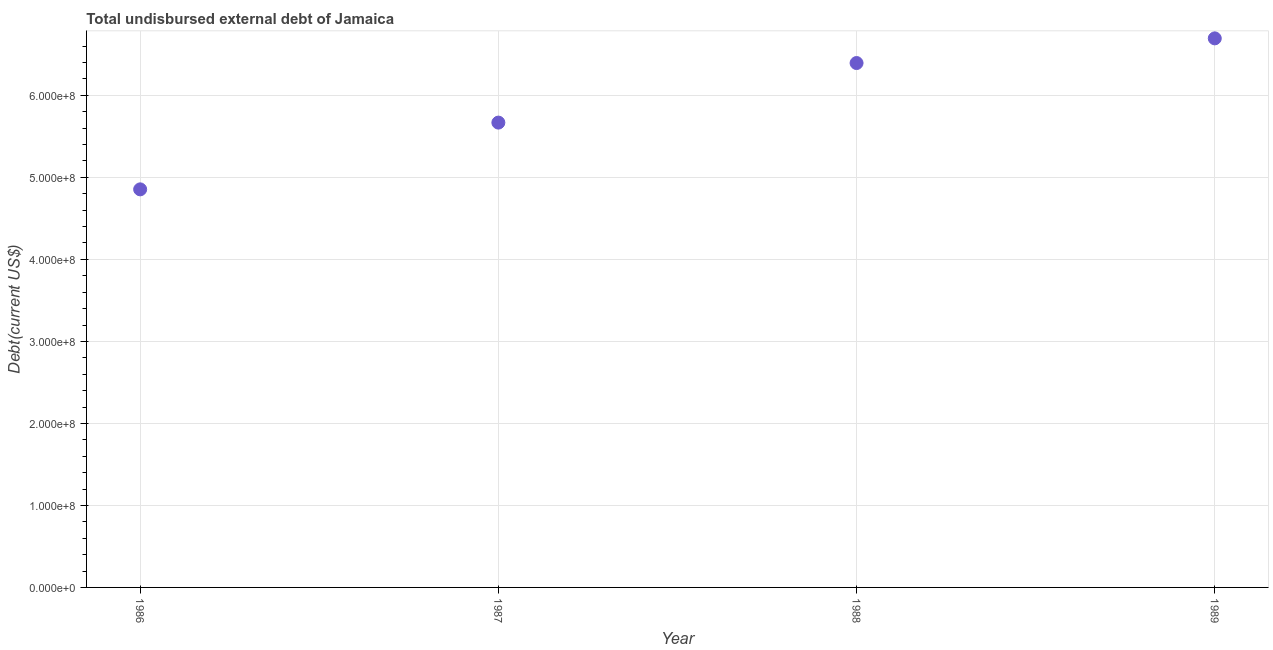What is the total debt in 1989?
Your answer should be very brief. 6.70e+08. Across all years, what is the maximum total debt?
Your answer should be very brief. 6.70e+08. Across all years, what is the minimum total debt?
Ensure brevity in your answer.  4.85e+08. In which year was the total debt maximum?
Provide a succinct answer. 1989. In which year was the total debt minimum?
Your answer should be compact. 1986. What is the sum of the total debt?
Your answer should be very brief. 2.36e+09. What is the difference between the total debt in 1987 and 1989?
Your answer should be very brief. -1.03e+08. What is the average total debt per year?
Offer a very short reply. 5.90e+08. What is the median total debt?
Ensure brevity in your answer.  6.03e+08. In how many years, is the total debt greater than 100000000 US$?
Offer a very short reply. 4. Do a majority of the years between 1986 and 1988 (inclusive) have total debt greater than 100000000 US$?
Provide a succinct answer. Yes. What is the ratio of the total debt in 1986 to that in 1987?
Give a very brief answer. 0.86. Is the difference between the total debt in 1987 and 1988 greater than the difference between any two years?
Your response must be concise. No. What is the difference between the highest and the second highest total debt?
Make the answer very short. 3.01e+07. Is the sum of the total debt in 1987 and 1988 greater than the maximum total debt across all years?
Provide a succinct answer. Yes. What is the difference between the highest and the lowest total debt?
Your answer should be very brief. 1.84e+08. In how many years, is the total debt greater than the average total debt taken over all years?
Offer a terse response. 2. Does the total debt monotonically increase over the years?
Keep it short and to the point. Yes. How many dotlines are there?
Give a very brief answer. 1. What is the difference between two consecutive major ticks on the Y-axis?
Offer a very short reply. 1.00e+08. Are the values on the major ticks of Y-axis written in scientific E-notation?
Ensure brevity in your answer.  Yes. What is the title of the graph?
Provide a succinct answer. Total undisbursed external debt of Jamaica. What is the label or title of the Y-axis?
Make the answer very short. Debt(current US$). What is the Debt(current US$) in 1986?
Keep it short and to the point. 4.85e+08. What is the Debt(current US$) in 1987?
Provide a short and direct response. 5.67e+08. What is the Debt(current US$) in 1988?
Make the answer very short. 6.39e+08. What is the Debt(current US$) in 1989?
Your response must be concise. 6.70e+08. What is the difference between the Debt(current US$) in 1986 and 1987?
Your answer should be very brief. -8.14e+07. What is the difference between the Debt(current US$) in 1986 and 1988?
Offer a terse response. -1.54e+08. What is the difference between the Debt(current US$) in 1986 and 1989?
Provide a short and direct response. -1.84e+08. What is the difference between the Debt(current US$) in 1987 and 1988?
Your response must be concise. -7.26e+07. What is the difference between the Debt(current US$) in 1987 and 1989?
Give a very brief answer. -1.03e+08. What is the difference between the Debt(current US$) in 1988 and 1989?
Your answer should be compact. -3.01e+07. What is the ratio of the Debt(current US$) in 1986 to that in 1987?
Give a very brief answer. 0.86. What is the ratio of the Debt(current US$) in 1986 to that in 1988?
Give a very brief answer. 0.76. What is the ratio of the Debt(current US$) in 1986 to that in 1989?
Offer a terse response. 0.72. What is the ratio of the Debt(current US$) in 1987 to that in 1988?
Your response must be concise. 0.89. What is the ratio of the Debt(current US$) in 1987 to that in 1989?
Give a very brief answer. 0.85. What is the ratio of the Debt(current US$) in 1988 to that in 1989?
Your response must be concise. 0.95. 